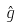<formula> <loc_0><loc_0><loc_500><loc_500>\hat { g }</formula> 